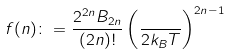Convert formula to latex. <formula><loc_0><loc_0><loc_500><loc_500>f ( n ) \colon = \frac { 2 ^ { 2 n } B _ { 2 n } } { ( 2 n ) ! } \left ( \frac { } { 2 k _ { B } T } \right ) ^ { 2 n - 1 }</formula> 